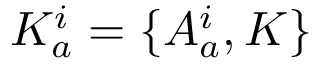<formula> <loc_0><loc_0><loc_500><loc_500>K _ { a } ^ { i } = \{ A _ { a } ^ { i } , K \}</formula> 